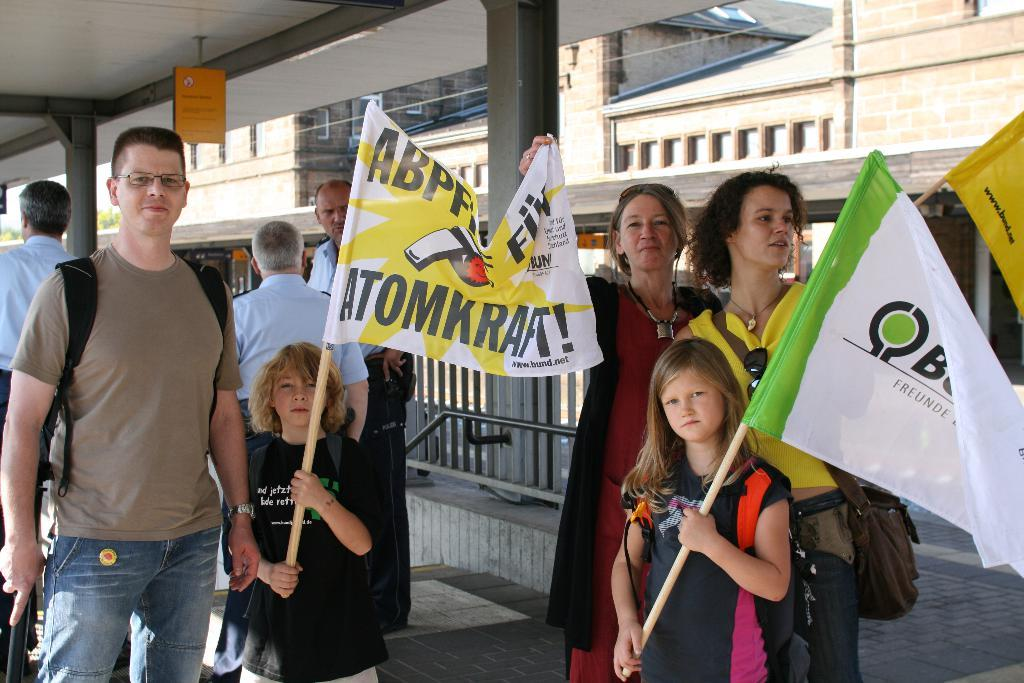How many people are standing in the image? There are persons standing in the image. Can you identify any specific individuals among the standing persons? Two kids are among the standing persons. What are the kids holding in the image? The two kids are holding flags. How are the flags attached to the kids? The flags are attached to wooden sticks. Can you see a horse running in the background of the image? There is no horse or any background visible in the image; it only shows persons standing with flags. 